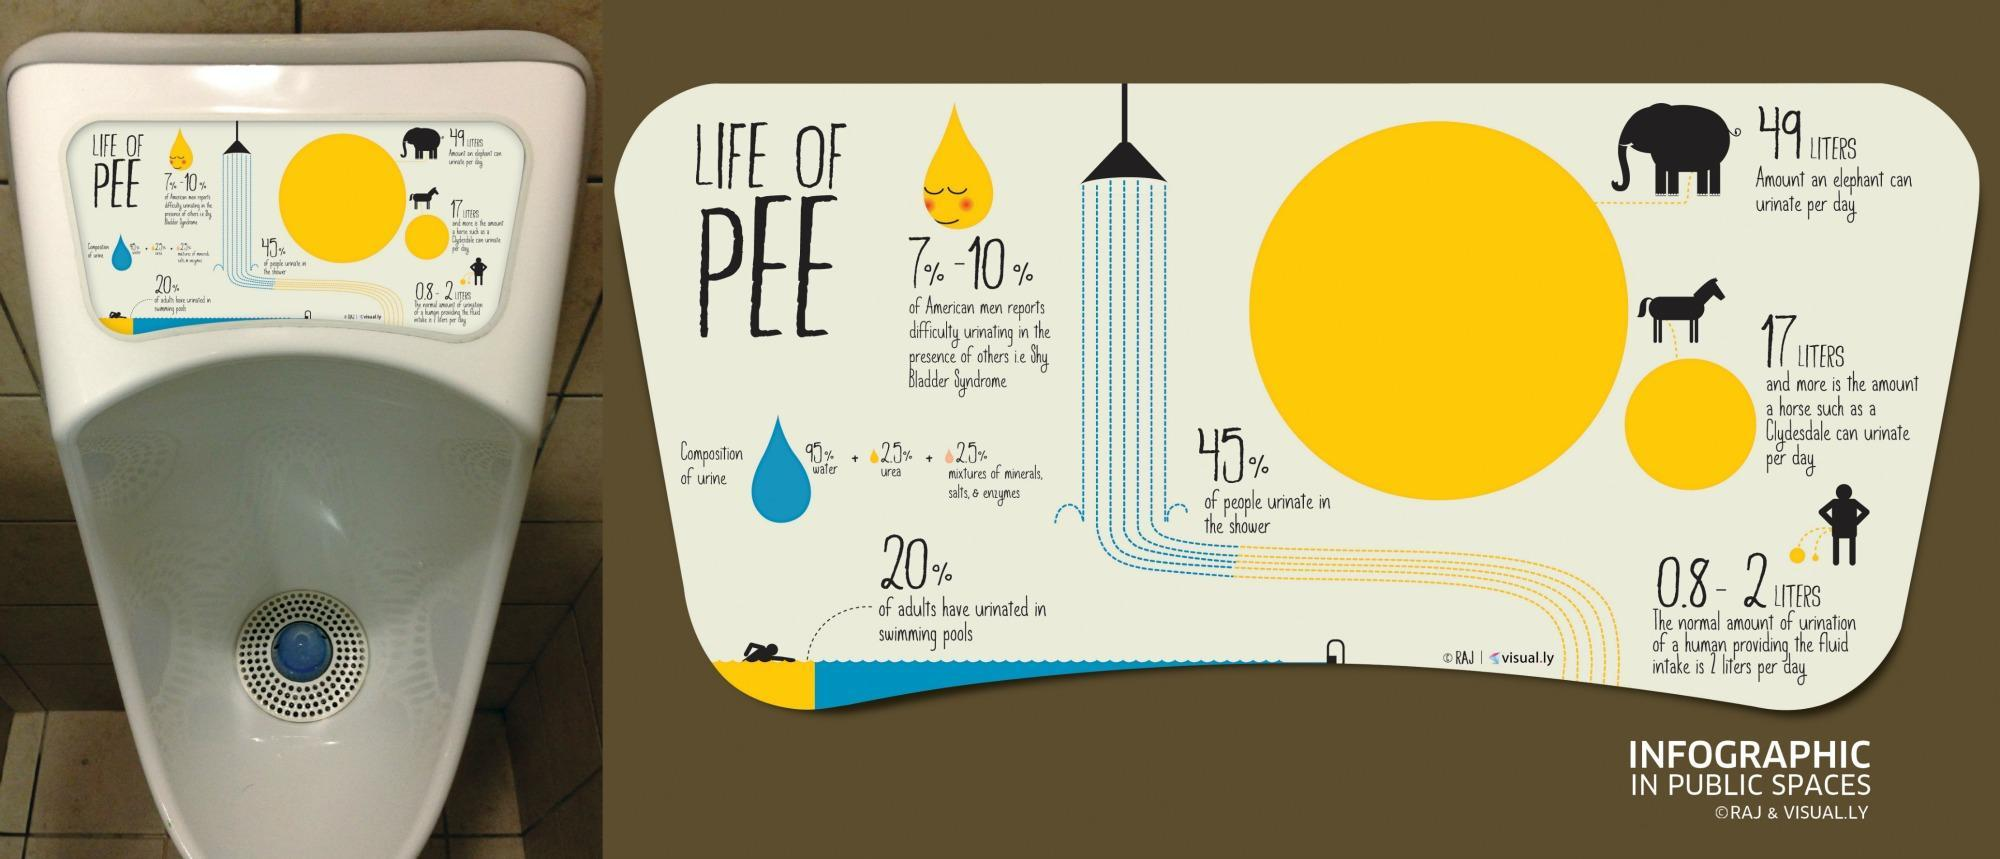What percentage of people do not urinate in shower?
Answer the question with a short phrase. 55% In the infographic shown, which animal urinates the most during a day? elephant 